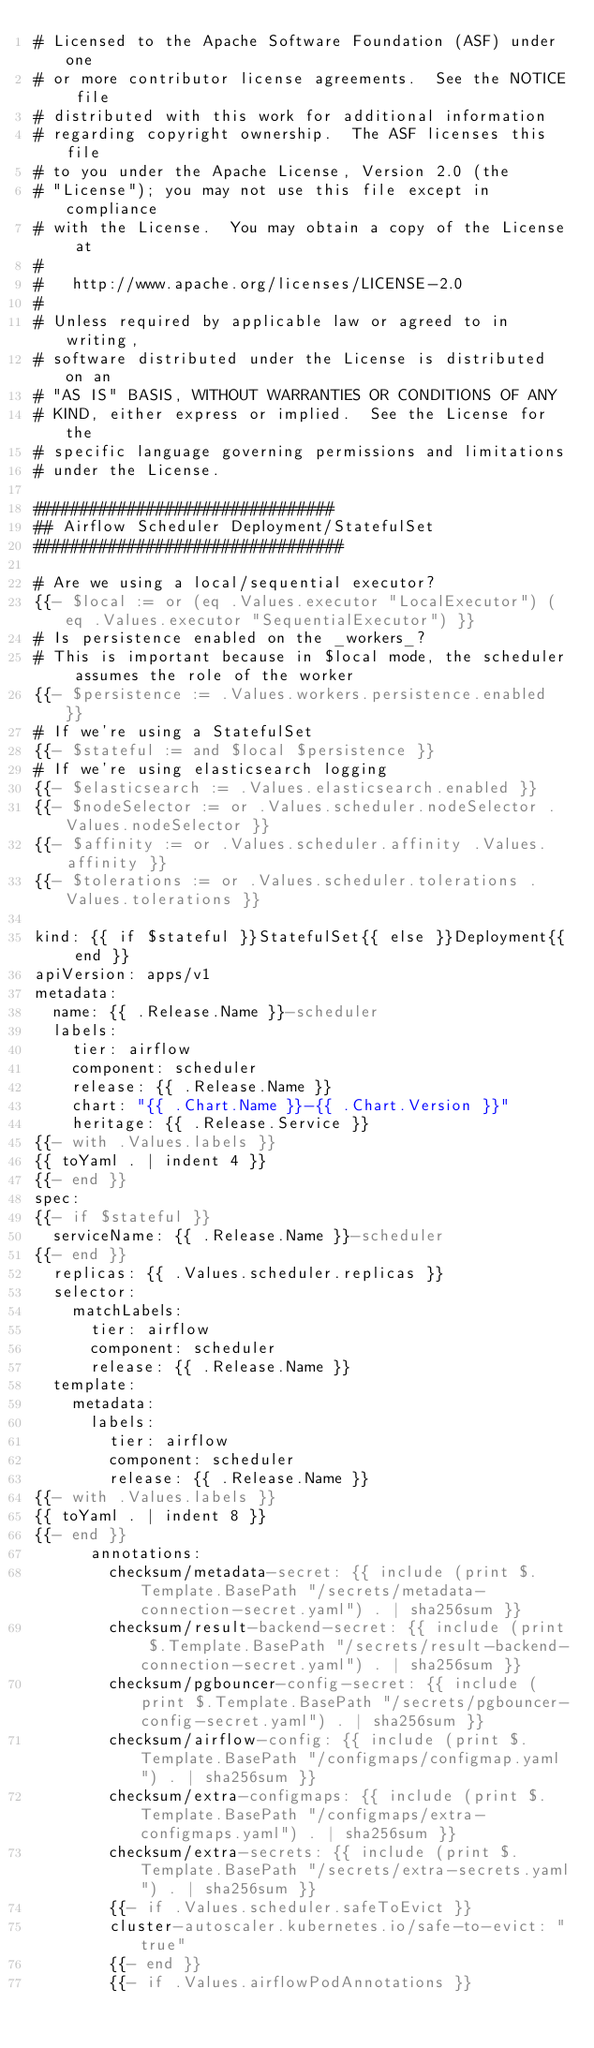Convert code to text. <code><loc_0><loc_0><loc_500><loc_500><_YAML_># Licensed to the Apache Software Foundation (ASF) under one
# or more contributor license agreements.  See the NOTICE file
# distributed with this work for additional information
# regarding copyright ownership.  The ASF licenses this file
# to you under the Apache License, Version 2.0 (the
# "License"); you may not use this file except in compliance
# with the License.  You may obtain a copy of the License at
#
#   http://www.apache.org/licenses/LICENSE-2.0
#
# Unless required by applicable law or agreed to in writing,
# software distributed under the License is distributed on an
# "AS IS" BASIS, WITHOUT WARRANTIES OR CONDITIONS OF ANY
# KIND, either express or implied.  See the License for the
# specific language governing permissions and limitations
# under the License.

################################
## Airflow Scheduler Deployment/StatefulSet
#################################

# Are we using a local/sequential executor?
{{- $local := or (eq .Values.executor "LocalExecutor") (eq .Values.executor "SequentialExecutor") }}
# Is persistence enabled on the _workers_?
# This is important because in $local mode, the scheduler assumes the role of the worker
{{- $persistence := .Values.workers.persistence.enabled }}
# If we're using a StatefulSet
{{- $stateful := and $local $persistence }}
# If we're using elasticsearch logging
{{- $elasticsearch := .Values.elasticsearch.enabled }}
{{- $nodeSelector := or .Values.scheduler.nodeSelector .Values.nodeSelector }}
{{- $affinity := or .Values.scheduler.affinity .Values.affinity }}
{{- $tolerations := or .Values.scheduler.tolerations .Values.tolerations }}

kind: {{ if $stateful }}StatefulSet{{ else }}Deployment{{ end }}
apiVersion: apps/v1
metadata:
  name: {{ .Release.Name }}-scheduler
  labels:
    tier: airflow
    component: scheduler
    release: {{ .Release.Name }}
    chart: "{{ .Chart.Name }}-{{ .Chart.Version }}"
    heritage: {{ .Release.Service }}
{{- with .Values.labels }}
{{ toYaml . | indent 4 }}
{{- end }}
spec:
{{- if $stateful }}
  serviceName: {{ .Release.Name }}-scheduler
{{- end }}
  replicas: {{ .Values.scheduler.replicas }}
  selector:
    matchLabels:
      tier: airflow
      component: scheduler
      release: {{ .Release.Name }}
  template:
    metadata:
      labels:
        tier: airflow
        component: scheduler
        release: {{ .Release.Name }}
{{- with .Values.labels }}
{{ toYaml . | indent 8 }}
{{- end }}
      annotations:
        checksum/metadata-secret: {{ include (print $.Template.BasePath "/secrets/metadata-connection-secret.yaml") . | sha256sum }}
        checksum/result-backend-secret: {{ include (print $.Template.BasePath "/secrets/result-backend-connection-secret.yaml") . | sha256sum }}
        checksum/pgbouncer-config-secret: {{ include (print $.Template.BasePath "/secrets/pgbouncer-config-secret.yaml") . | sha256sum }}
        checksum/airflow-config: {{ include (print $.Template.BasePath "/configmaps/configmap.yaml") . | sha256sum }}
        checksum/extra-configmaps: {{ include (print $.Template.BasePath "/configmaps/extra-configmaps.yaml") . | sha256sum }}
        checksum/extra-secrets: {{ include (print $.Template.BasePath "/secrets/extra-secrets.yaml") . | sha256sum }}
        {{- if .Values.scheduler.safeToEvict }}
        cluster-autoscaler.kubernetes.io/safe-to-evict: "true"
        {{- end }}
        {{- if .Values.airflowPodAnnotations }}</code> 